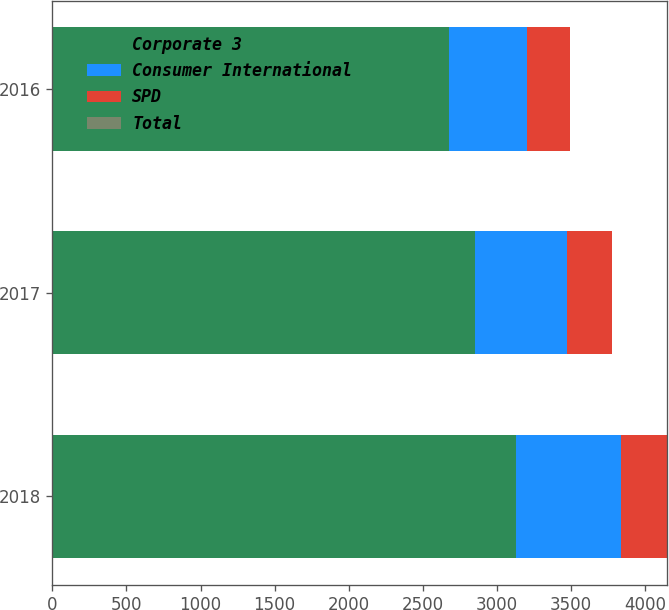Convert chart to OTSL. <chart><loc_0><loc_0><loc_500><loc_500><stacked_bar_chart><ecel><fcel>2018<fcel>2017<fcel>2016<nl><fcel>Corporate 3<fcel>3129.9<fcel>2854.9<fcel>2677.8<nl><fcel>Consumer International<fcel>709.5<fcel>621.1<fcel>525.2<nl><fcel>SPD<fcel>306.5<fcel>300.2<fcel>290.1<nl><fcel>Total<fcel>0<fcel>0<fcel>0<nl></chart> 